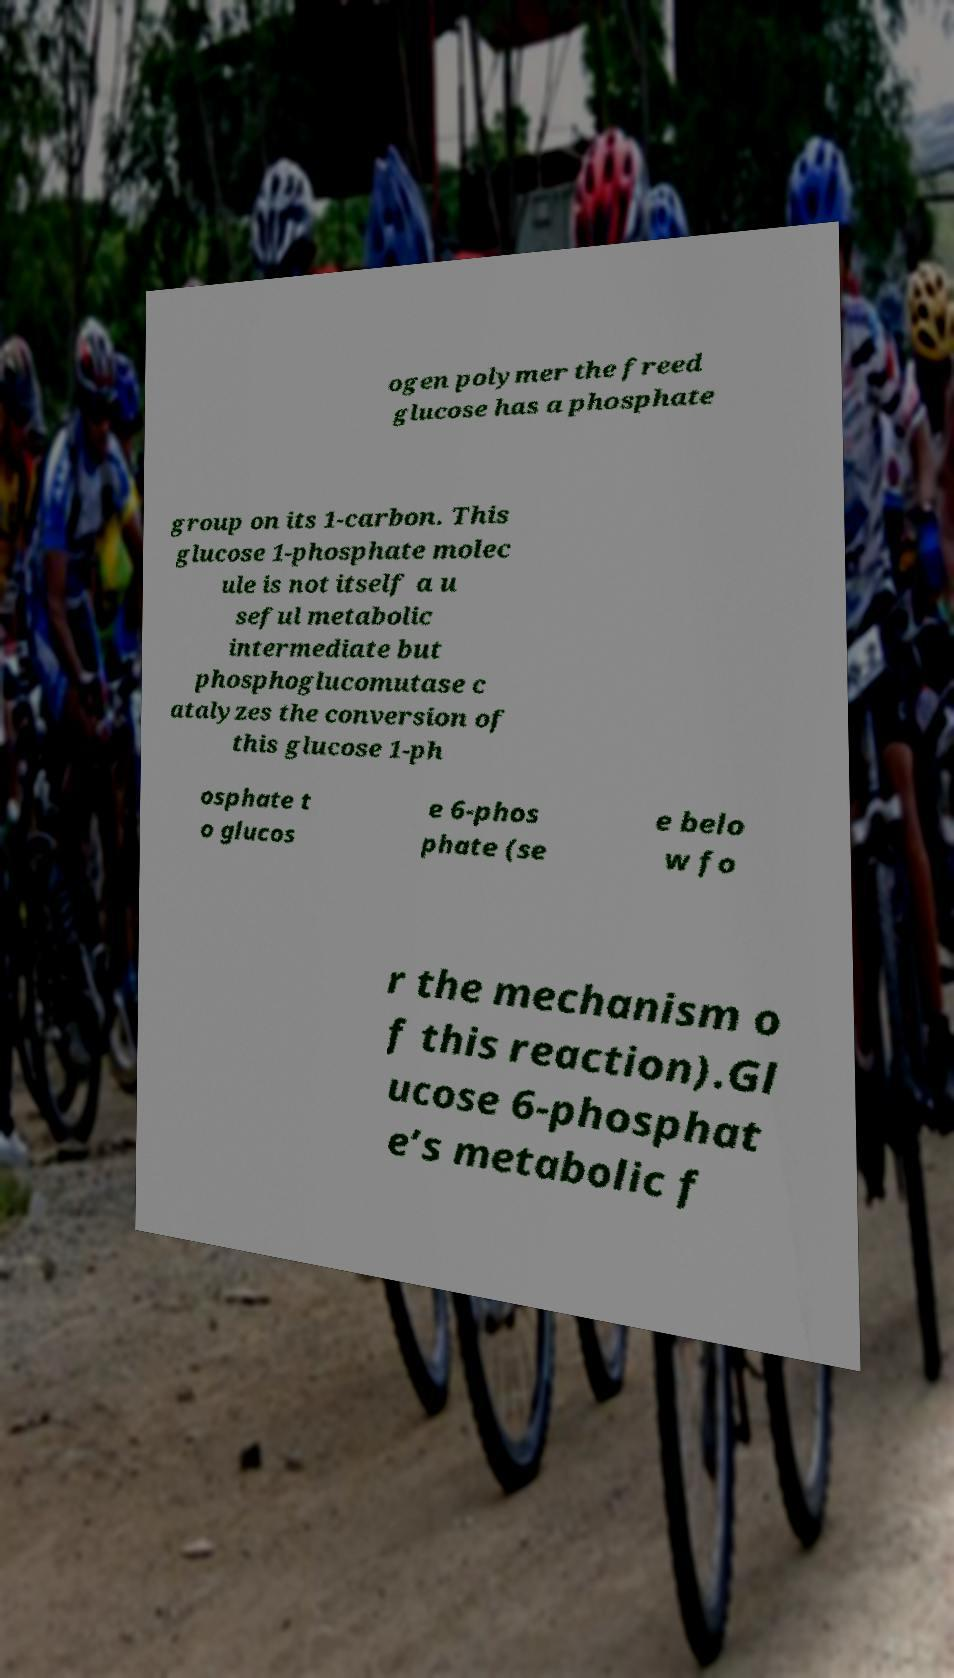There's text embedded in this image that I need extracted. Can you transcribe it verbatim? ogen polymer the freed glucose has a phosphate group on its 1-carbon. This glucose 1-phosphate molec ule is not itself a u seful metabolic intermediate but phosphoglucomutase c atalyzes the conversion of this glucose 1-ph osphate t o glucos e 6-phos phate (se e belo w fo r the mechanism o f this reaction).Gl ucose 6-phosphat e’s metabolic f 